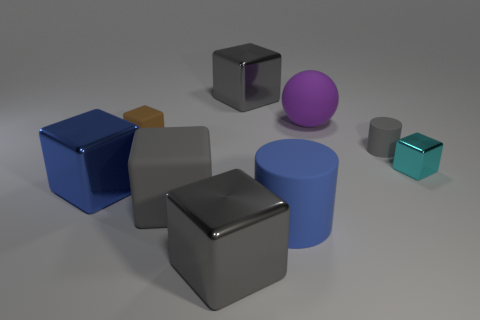Subtract all brown balls. How many gray blocks are left? 3 Subtract all large rubber blocks. How many blocks are left? 5 Subtract all cyan blocks. How many blocks are left? 5 Subtract all gray spheres. Subtract all blue cubes. How many spheres are left? 1 Subtract all balls. How many objects are left? 8 Add 5 tiny cyan shiny cubes. How many tiny cyan shiny cubes exist? 6 Subtract 0 green spheres. How many objects are left? 9 Subtract all brown spheres. Subtract all small brown rubber objects. How many objects are left? 8 Add 3 matte balls. How many matte balls are left? 4 